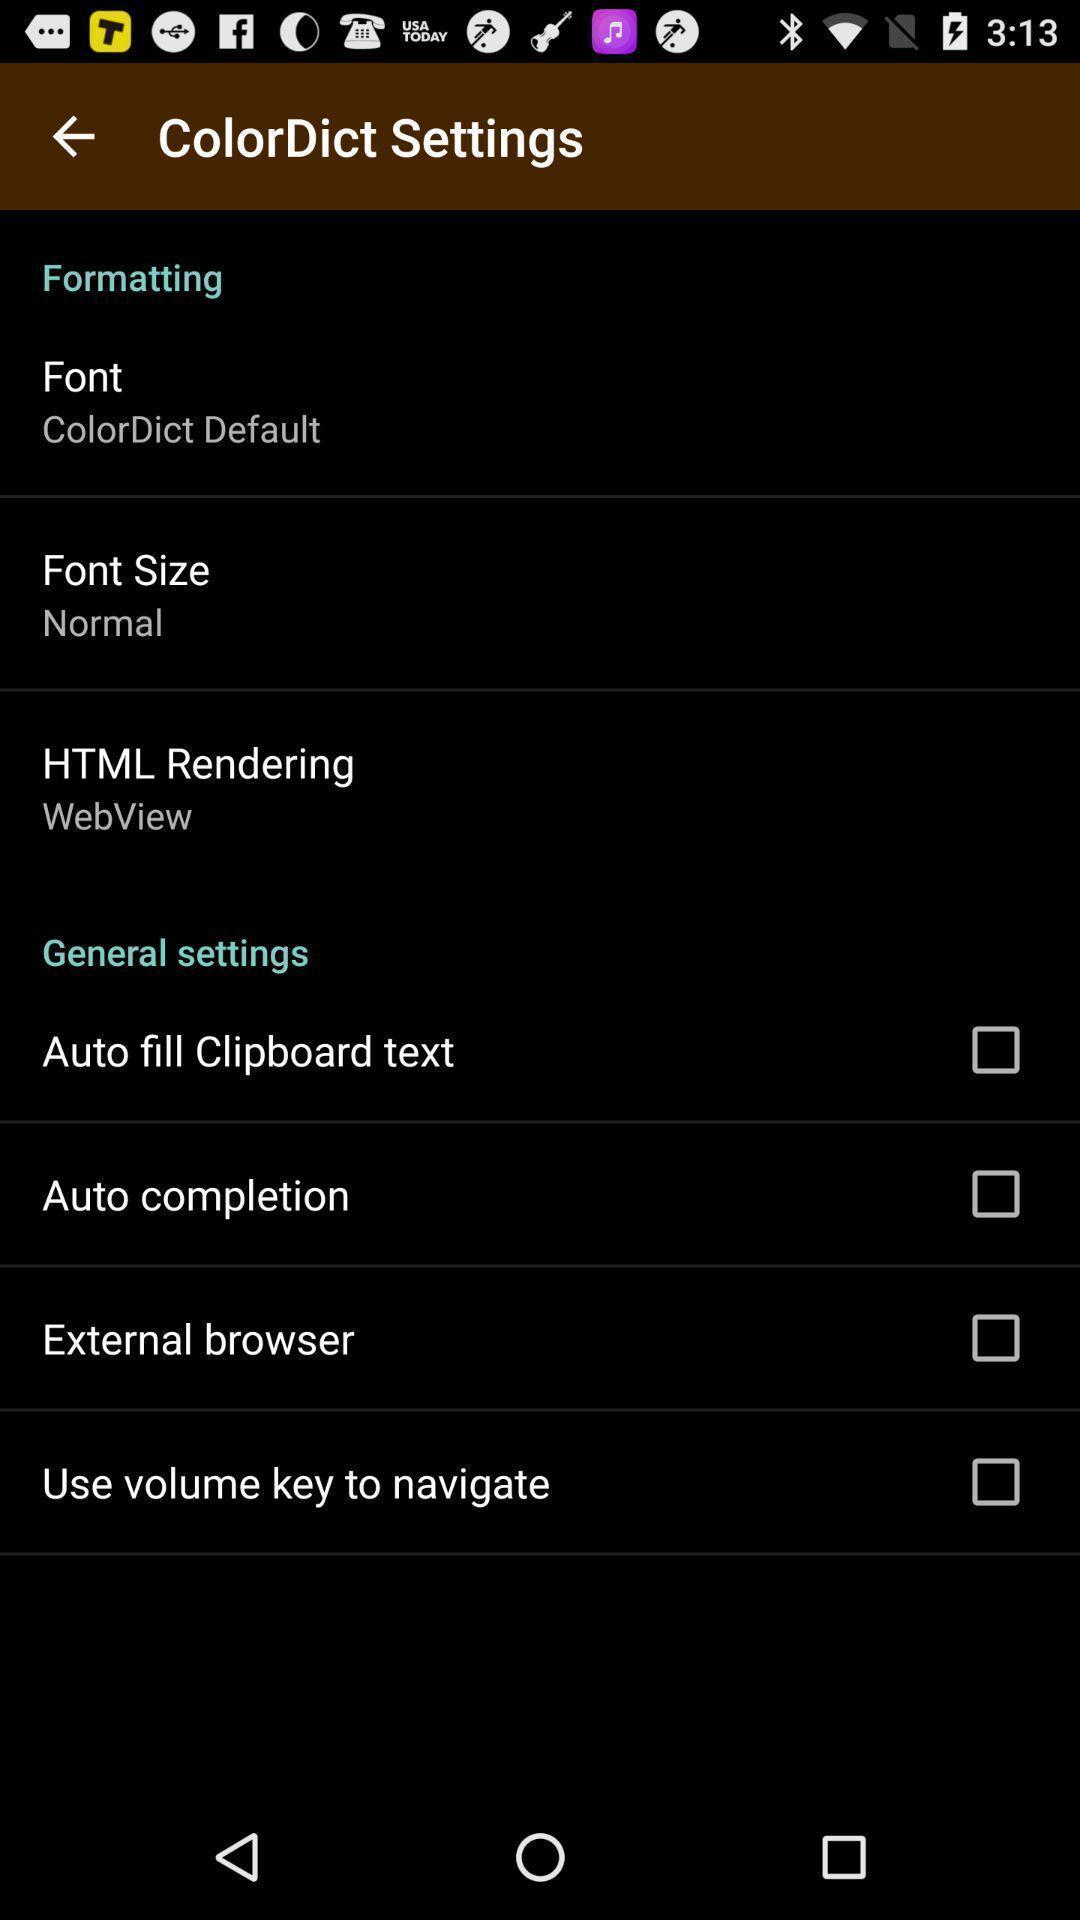Summarize the main components in this picture. Settings page of a dictionary app. 